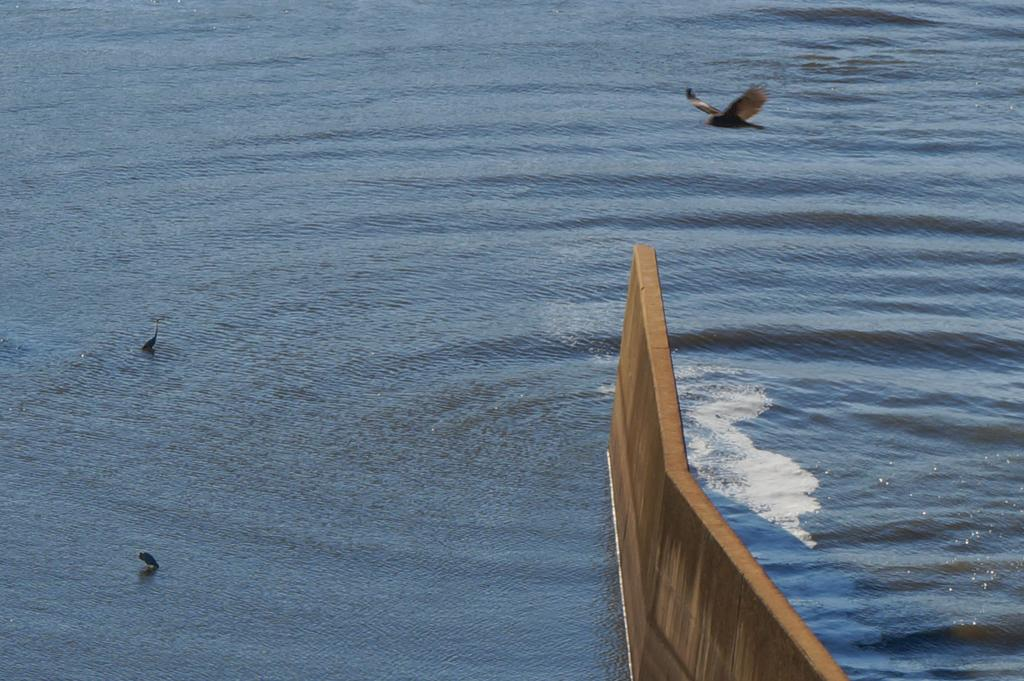What is the primary element in the image? There is water in the image. What can be seen on the water? There are two birds on the water. What is one bird doing in the image? One bird is flying. What is located at the bottom of the image? There is a wall at the bottom of the image. What type of metal beam can be seen supporting the birds in the image? There is no metal beam present in the image; the birds are on the water, not supported by any structure. 